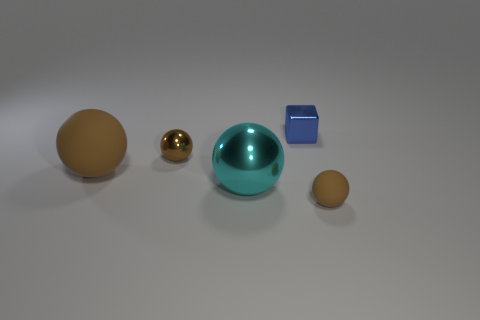Subtract all red blocks. How many brown spheres are left? 3 Subtract 1 balls. How many balls are left? 3 Subtract all cyan balls. How many balls are left? 3 Subtract all brown spheres. How many spheres are left? 1 Add 1 cyan shiny things. How many objects exist? 6 Subtract all red balls. Subtract all green cubes. How many balls are left? 4 Subtract all blocks. How many objects are left? 4 Add 3 cyan shiny spheres. How many cyan shiny spheres exist? 4 Subtract 0 cyan cylinders. How many objects are left? 5 Subtract all small red things. Subtract all cyan objects. How many objects are left? 4 